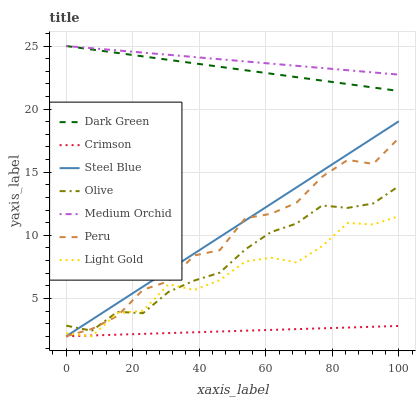Does Crimson have the minimum area under the curve?
Answer yes or no. Yes. Does Medium Orchid have the maximum area under the curve?
Answer yes or no. Yes. Does Steel Blue have the minimum area under the curve?
Answer yes or no. No. Does Steel Blue have the maximum area under the curve?
Answer yes or no. No. Is Dark Green the smoothest?
Answer yes or no. Yes. Is Light Gold the roughest?
Answer yes or no. Yes. Is Steel Blue the smoothest?
Answer yes or no. No. Is Steel Blue the roughest?
Answer yes or no. No. Does Steel Blue have the lowest value?
Answer yes or no. Yes. Does Olive have the lowest value?
Answer yes or no. No. Does Dark Green have the highest value?
Answer yes or no. Yes. Does Steel Blue have the highest value?
Answer yes or no. No. Is Steel Blue less than Medium Orchid?
Answer yes or no. Yes. Is Medium Orchid greater than Olive?
Answer yes or no. Yes. Does Olive intersect Peru?
Answer yes or no. Yes. Is Olive less than Peru?
Answer yes or no. No. Is Olive greater than Peru?
Answer yes or no. No. Does Steel Blue intersect Medium Orchid?
Answer yes or no. No. 